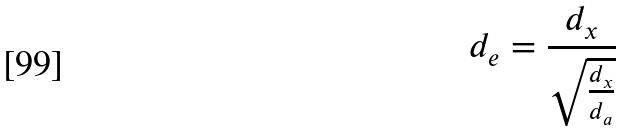<formula> <loc_0><loc_0><loc_500><loc_500>d _ { e } = \frac { d _ { x } } { \sqrt { \frac { d _ { x } } { d _ { a } } } }</formula> 